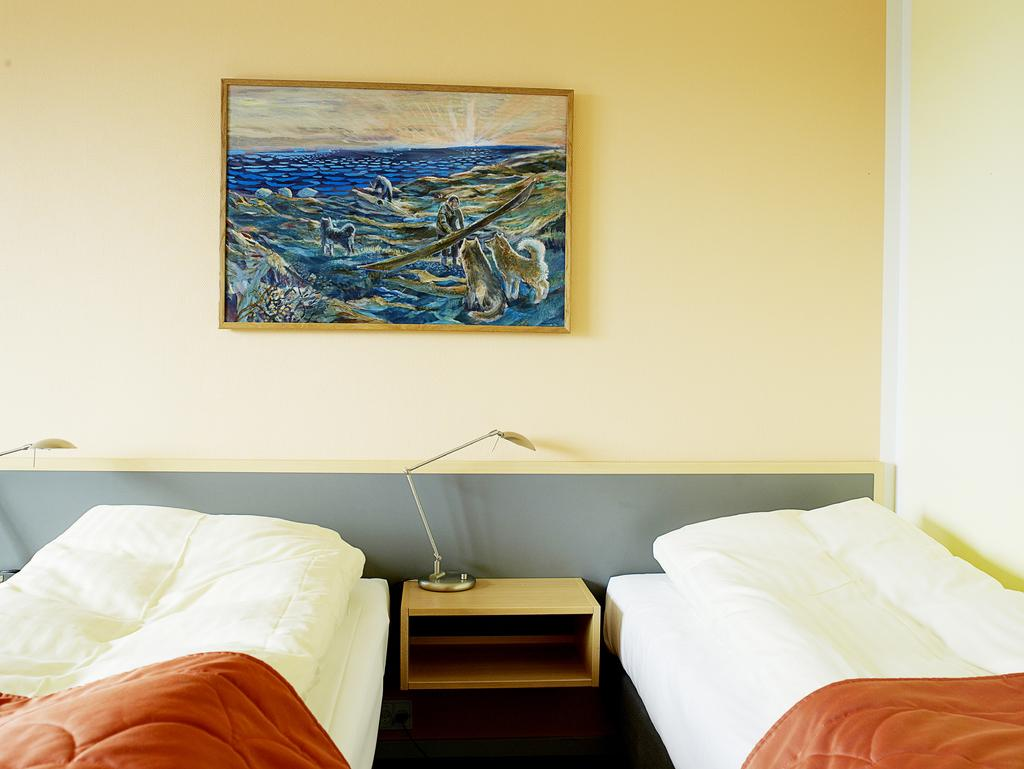How many beds are visible in the image? There are two beds in the image. What is located in the middle of the image? There is a painting in the middle of the image. How is the painting positioned in the image? The painting is attached to the wall. What type of fowl can be seen sitting on the cushion in the image? There is no fowl or cushion present in the image. 